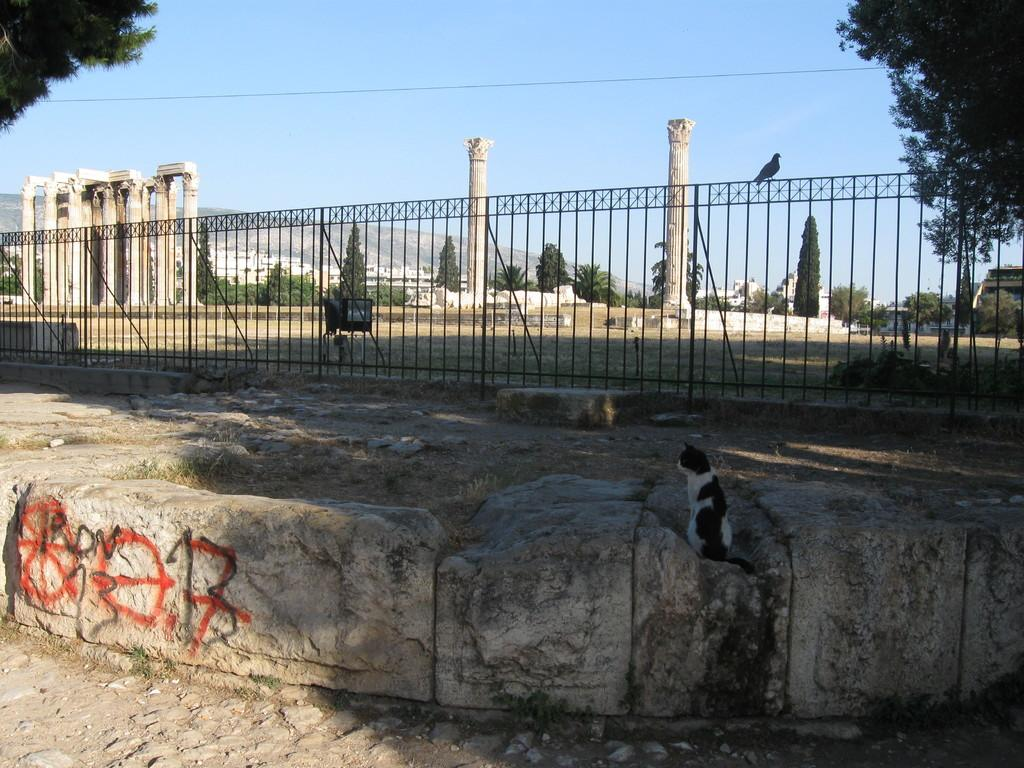What animal is seated on a rock in the image? There is a cat seated on a rock in the image. What other animal can be seen in the image? There is a bird on a fence in the image. What type of vegetation is visible in the background of the image? There are trees in the background of the image. What architectural features can be seen in the background of the image? There are pillars in the background of the image. What type of landscape is visible in the background of the image? There are hills in the background of the image. How many clovers can be seen in the image? There are no clovers present in the image. 